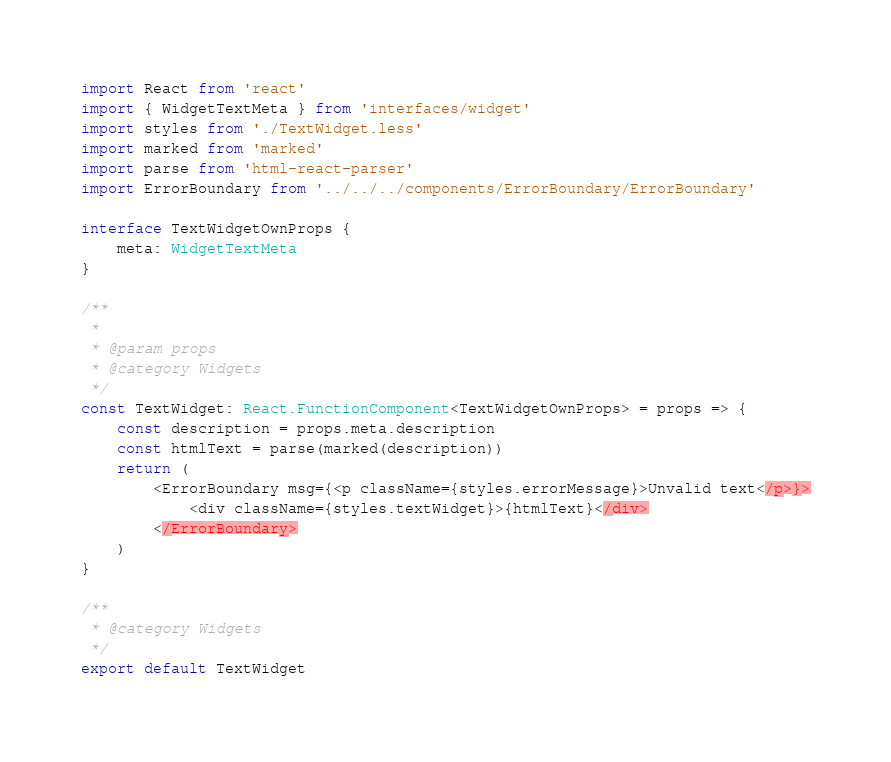<code> <loc_0><loc_0><loc_500><loc_500><_TypeScript_>import React from 'react'
import { WidgetTextMeta } from 'interfaces/widget'
import styles from './TextWidget.less'
import marked from 'marked'
import parse from 'html-react-parser'
import ErrorBoundary from '../../../components/ErrorBoundary/ErrorBoundary'

interface TextWidgetOwnProps {
    meta: WidgetTextMeta
}

/**
 *
 * @param props
 * @category Widgets
 */
const TextWidget: React.FunctionComponent<TextWidgetOwnProps> = props => {
    const description = props.meta.description
    const htmlText = parse(marked(description))
    return (
        <ErrorBoundary msg={<p className={styles.errorMessage}>Unvalid text</p>}>
            <div className={styles.textWidget}>{htmlText}</div>
        </ErrorBoundary>
    )
}

/**
 * @category Widgets
 */
export default TextWidget
</code> 